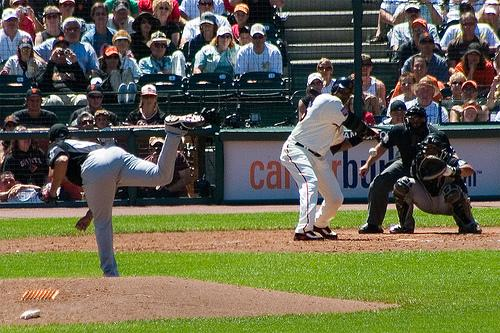What is the sponsor's industry? Please explain your reasoning. job search. It's for job searching. 